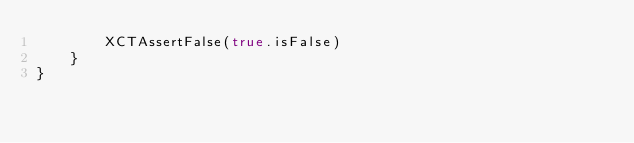Convert code to text. <code><loc_0><loc_0><loc_500><loc_500><_Swift_>        XCTAssertFalse(true.isFalse)
    }
}
</code> 